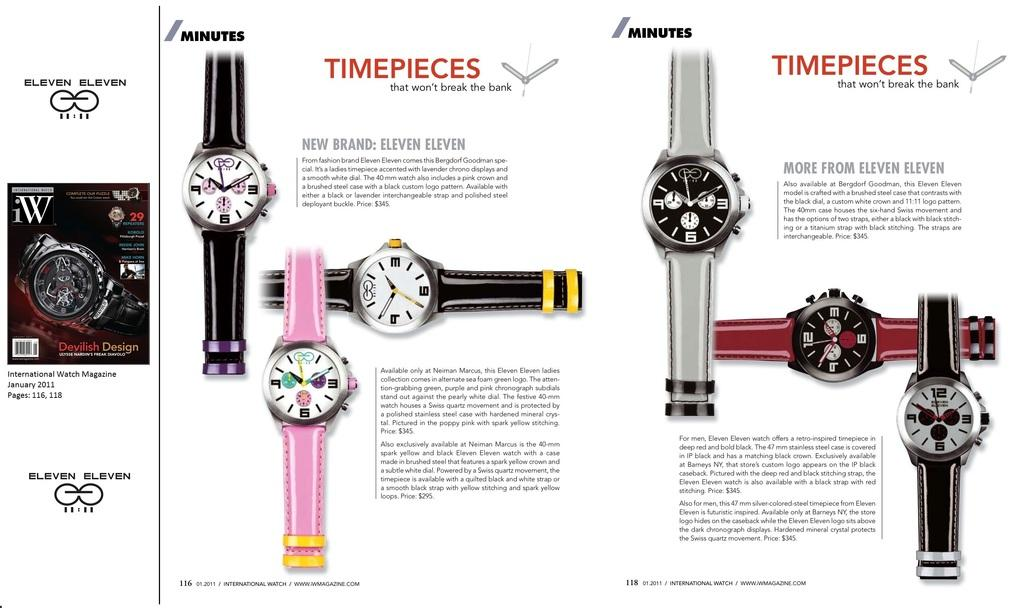<image>
Offer a succinct explanation of the picture presented. The watches are made by the brand eleven eleven. 